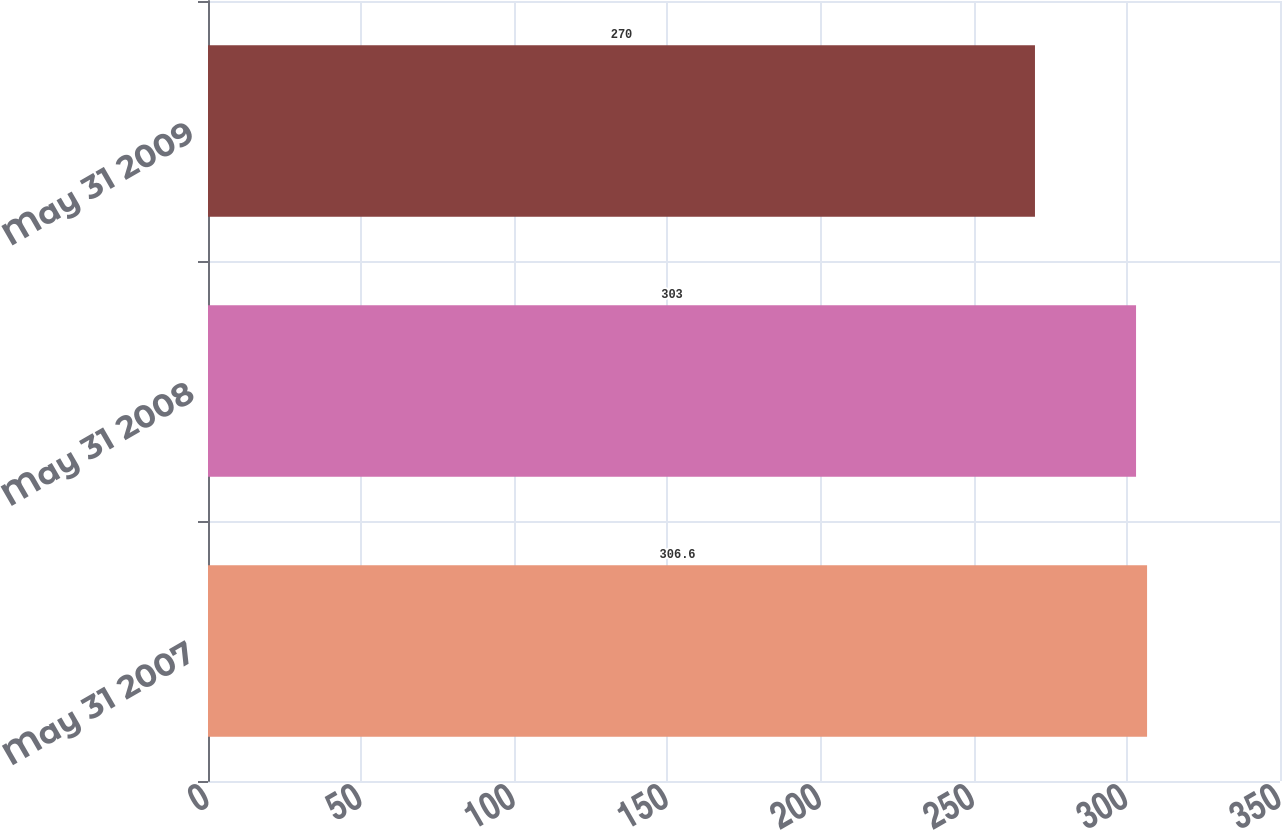<chart> <loc_0><loc_0><loc_500><loc_500><bar_chart><fcel>May 31 2007<fcel>May 31 2008<fcel>May 31 2009<nl><fcel>306.6<fcel>303<fcel>270<nl></chart> 